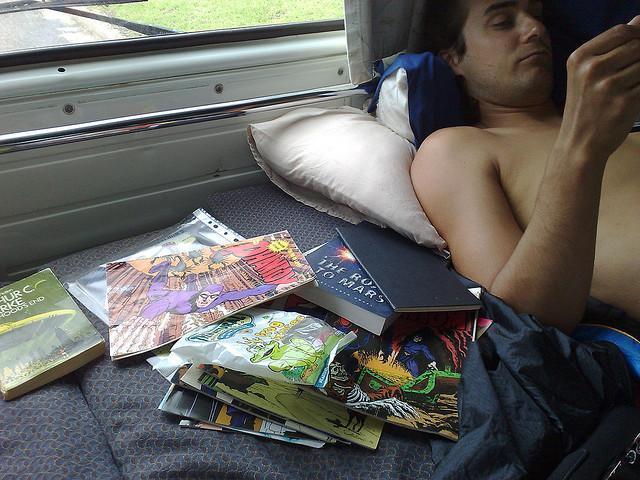How many people are there?
Give a very brief answer. 1. How many books can be seen?
Give a very brief answer. 9. 